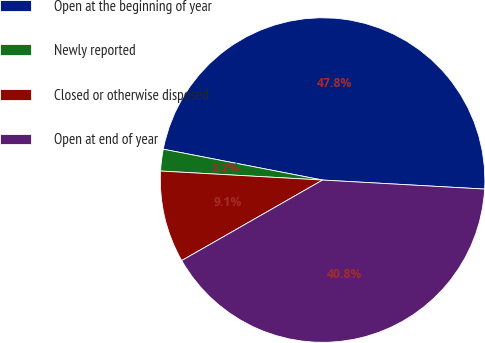Convert chart to OTSL. <chart><loc_0><loc_0><loc_500><loc_500><pie_chart><fcel>Open at the beginning of year<fcel>Newly reported<fcel>Closed or otherwise disposed<fcel>Open at end of year<nl><fcel>47.84%<fcel>2.16%<fcel>9.15%<fcel>40.85%<nl></chart> 